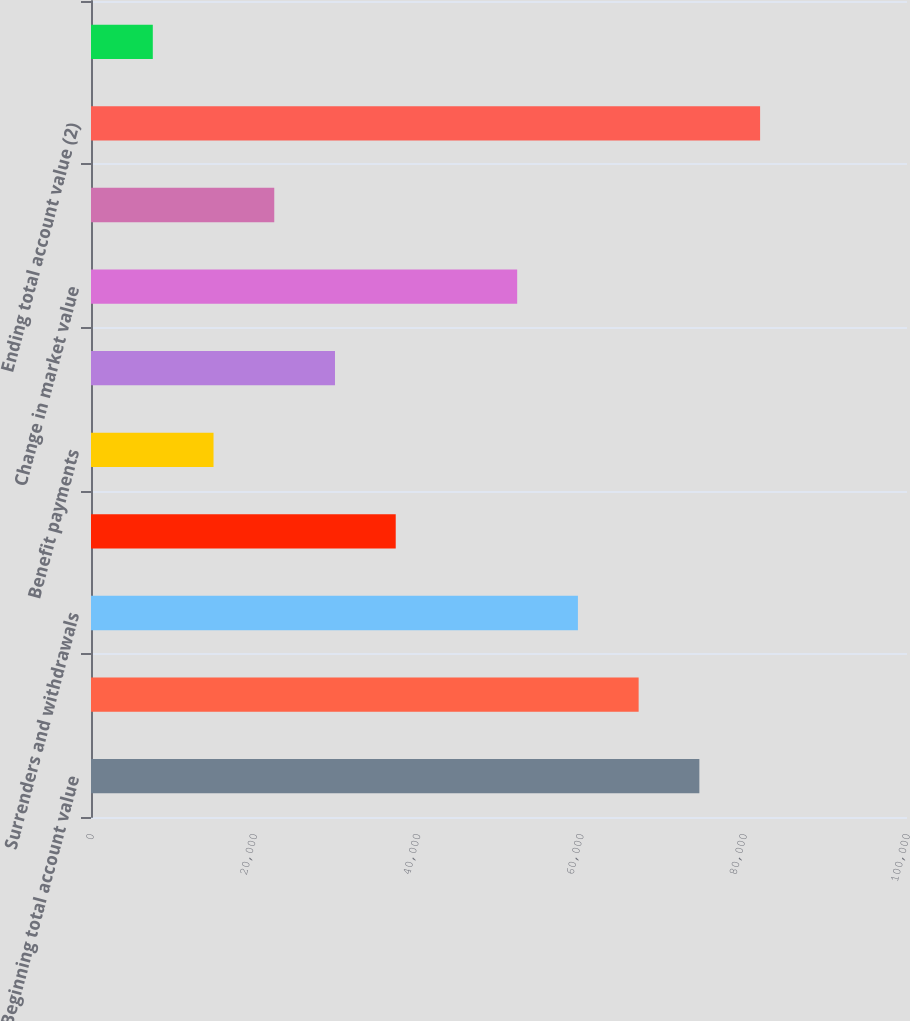<chart> <loc_0><loc_0><loc_500><loc_500><bar_chart><fcel>Beginning total account value<fcel>Sales<fcel>Surrenders and withdrawals<fcel>Net sales<fcel>Benefit payments<fcel>Net flows<fcel>Change in market value<fcel>Policy charges<fcel>Ending total account value (2)<fcel>Net sales (redemptions)<nl><fcel>74555<fcel>67112.6<fcel>59670.2<fcel>37343<fcel>15015.8<fcel>29900.6<fcel>52227.8<fcel>22458.2<fcel>81997.4<fcel>7573.4<nl></chart> 